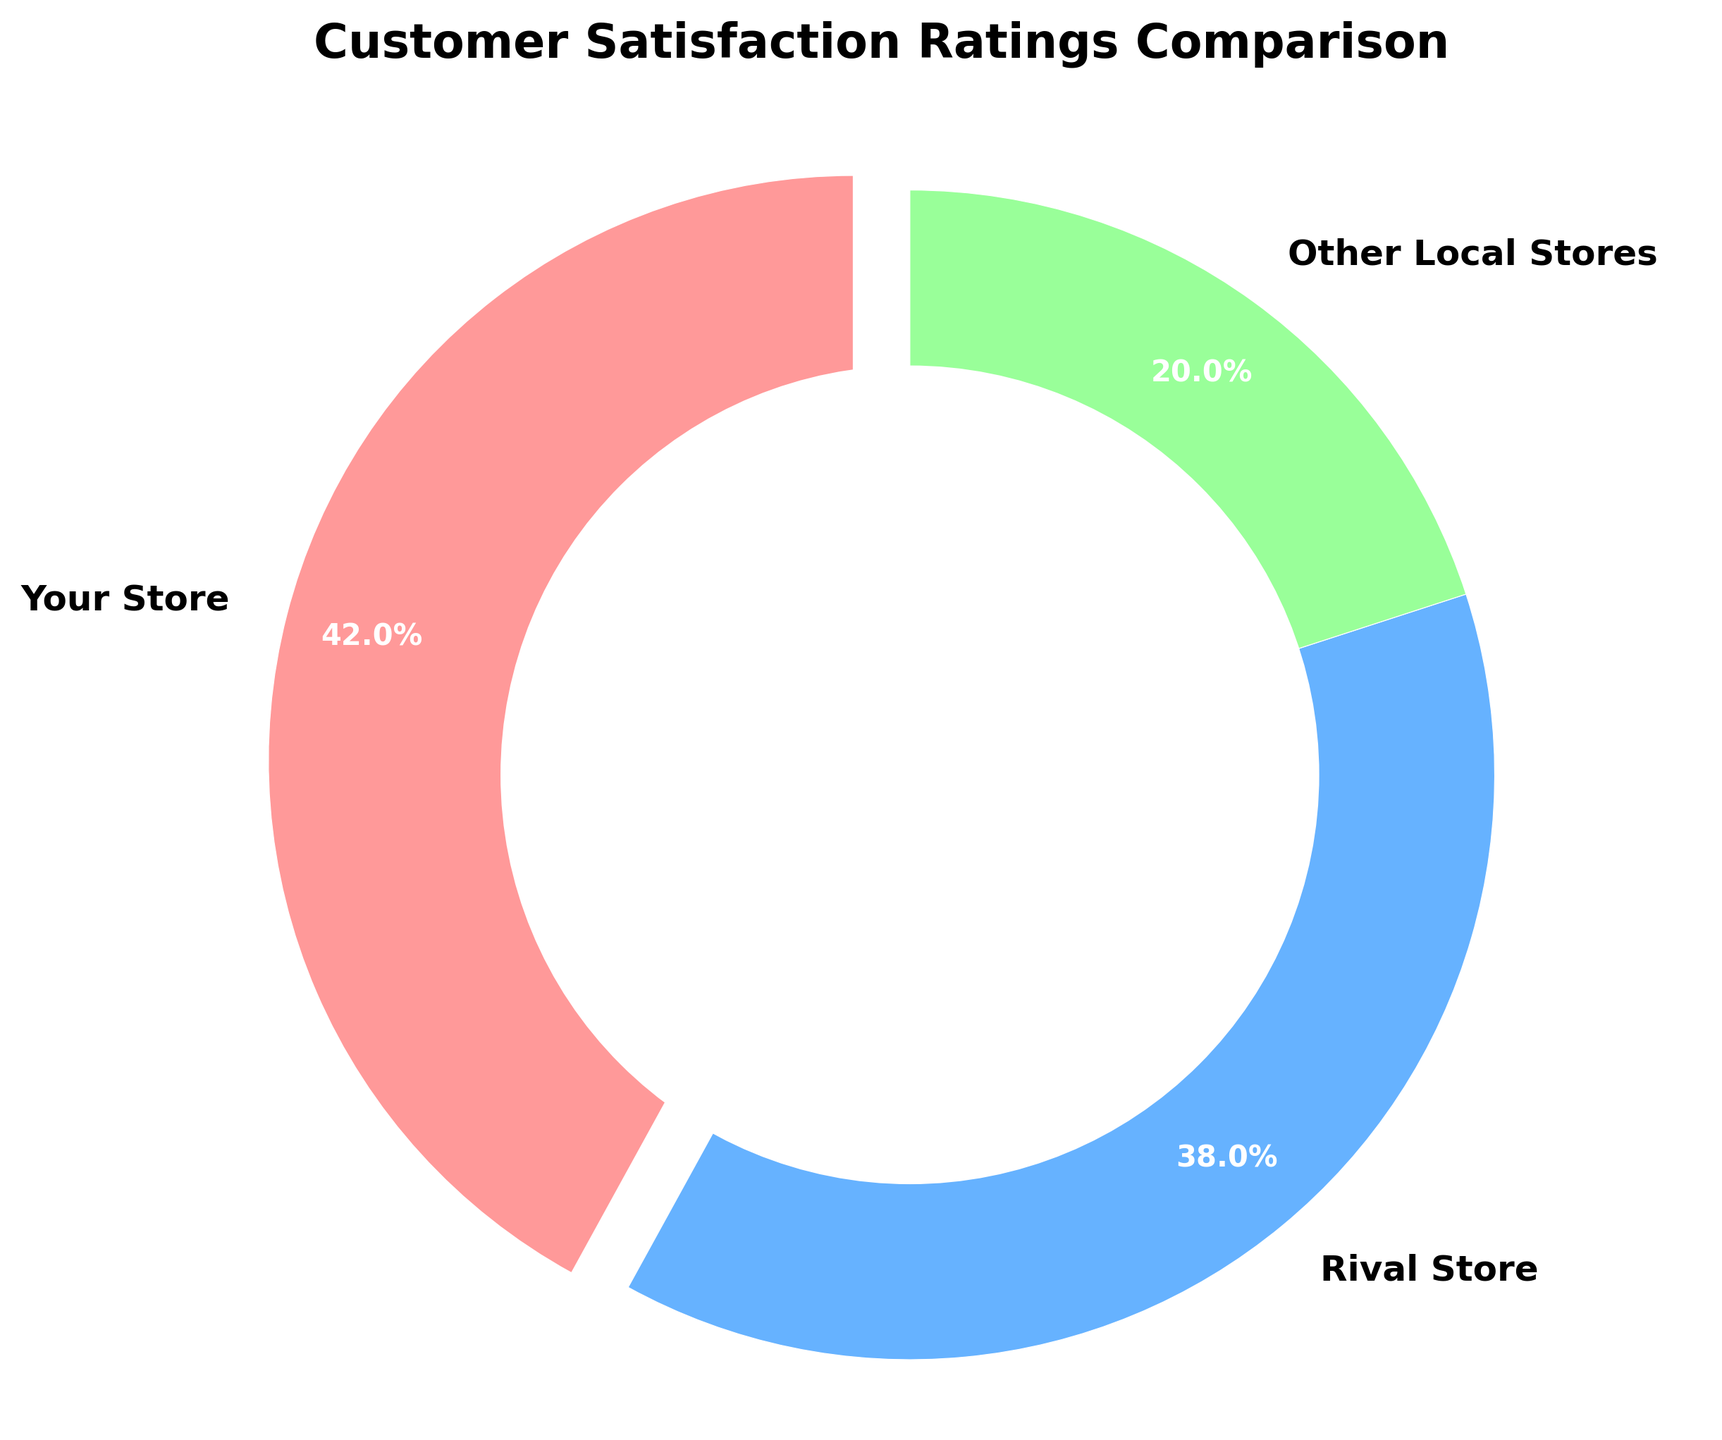Which store has the highest customer satisfaction rating? The pie chart shows three segments representing Your Store, Rival Store, and Other Local Stores. The segment labeled "Your Store" indicates a higher percentage than the others.
Answer: Your Store What is the percentage difference in satisfaction ratings between Your Store and Rival Store? From the pie chart, Your Store has 42% and the Rival Store has 38%. The difference is calculated as 42% - 38% = 4%.
Answer: 4% How does the satisfaction rating of Other Local Stores compare to that of Rival Store in terms of percentages? The pie chart shows Other Local Stores at 20% and Rival Store at 38%. To compare, subtract 20% from 38% which equals 18%.
Answer: 18% If the total satisfaction rating is 100%, what is the combined satisfaction rating of Rival Store and Other Local Stores? The pie chart shows the individual percentages: Rival Store has 38% and Other Local Stores have 20%. Adding these together gives 38% + 20% = 58%.
Answer: 58% Which segment of the pie chart makes use of the red color? By visually inspecting the pie chart, the red segment corresponds to Your Store.
Answer: Your Store By what percentage does Your Store's satisfaction rating exceed Other Local Stores' rating? Your Store is at 42% and Other Local Stores are at 20%. Subtracting these gives 42% - 20% = 22%.
Answer: 22% What fraction of the total ratings does Rival Store hold? Rival Store holds 38% of the total ratings. Converting this percentage to a fraction: 38% equals 38/100, which simplifies to 19/50.
Answer: 19/50 Which store’s satisfaction rating is closest to 40%? Visual inspection reveals that Rival Store’s satisfaction rating is closest to 40%, at 38%.
Answer: Rival Store 